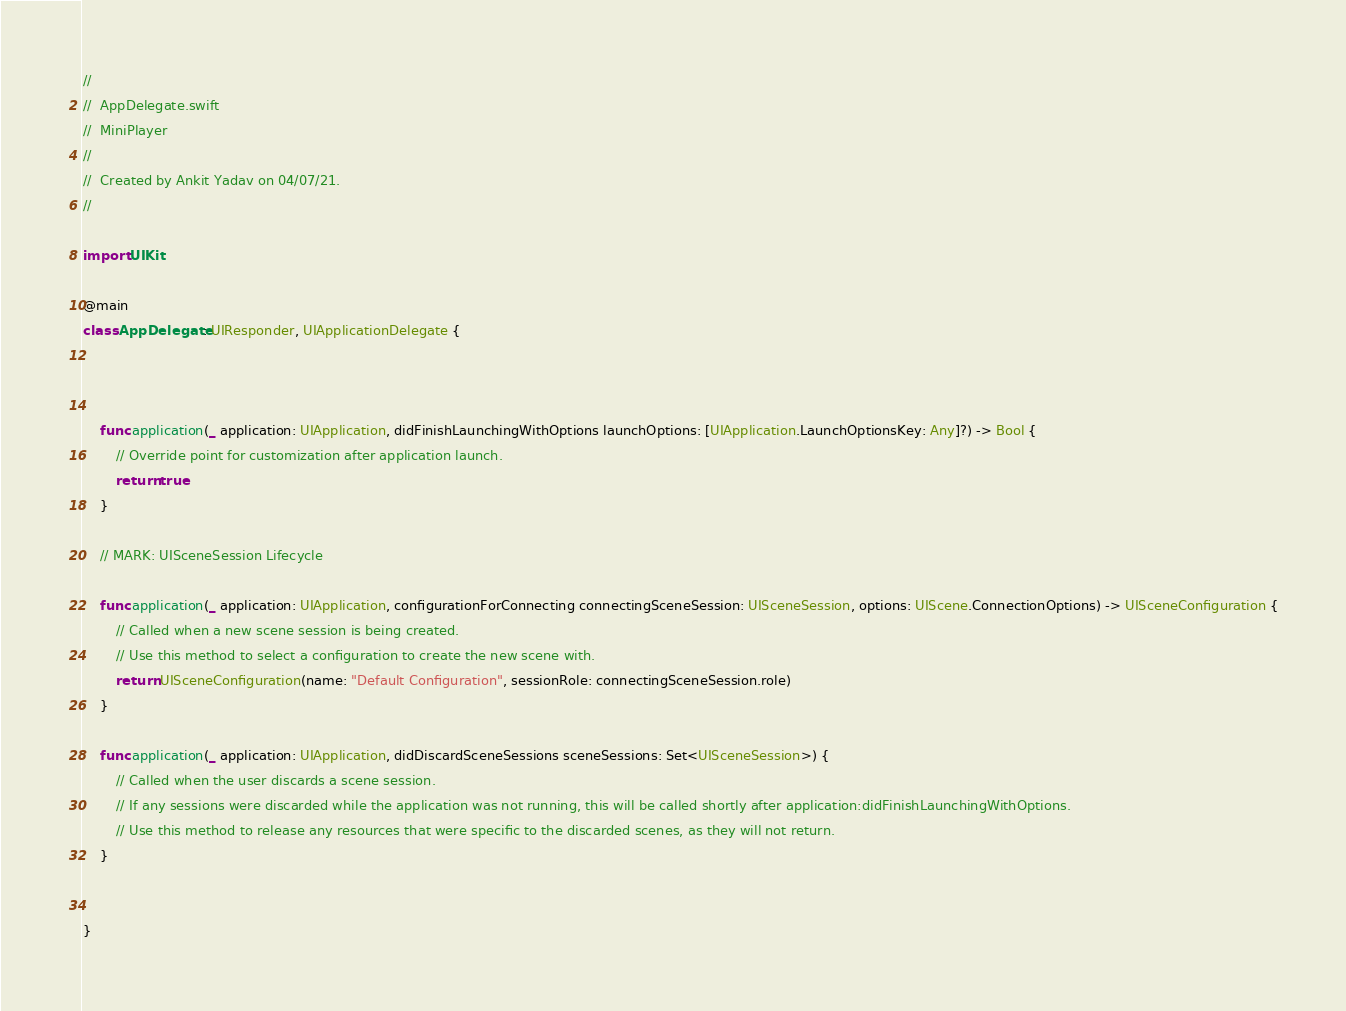Convert code to text. <code><loc_0><loc_0><loc_500><loc_500><_Swift_>//
//  AppDelegate.swift
//  MiniPlayer
//
//  Created by Ankit Yadav on 04/07/21.
//

import UIKit

@main
class AppDelegate: UIResponder, UIApplicationDelegate {



    func application(_ application: UIApplication, didFinishLaunchingWithOptions launchOptions: [UIApplication.LaunchOptionsKey: Any]?) -> Bool {
        // Override point for customization after application launch.
        return true
    }

    // MARK: UISceneSession Lifecycle

    func application(_ application: UIApplication, configurationForConnecting connectingSceneSession: UISceneSession, options: UIScene.ConnectionOptions) -> UISceneConfiguration {
        // Called when a new scene session is being created.
        // Use this method to select a configuration to create the new scene with.
        return UISceneConfiguration(name: "Default Configuration", sessionRole: connectingSceneSession.role)
    }

    func application(_ application: UIApplication, didDiscardSceneSessions sceneSessions: Set<UISceneSession>) {
        // Called when the user discards a scene session.
        // If any sessions were discarded while the application was not running, this will be called shortly after application:didFinishLaunchingWithOptions.
        // Use this method to release any resources that were specific to the discarded scenes, as they will not return.
    }


}

</code> 